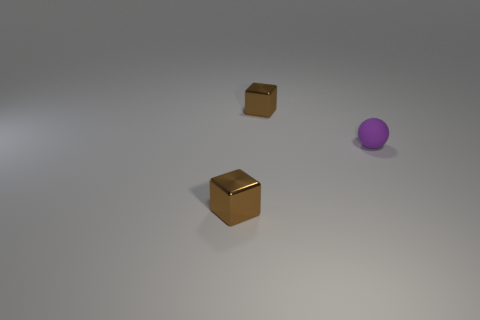What materials do the objects in the image appear to be made of? The objects in the image seem to be made of different materials. The smaller cube in the back appears to have a texture reminiscent of cardboard, while the larger, shiny cube in the foreground suggests a metallic composition. The purple object has a smooth surface which might indicate a plastic or painted wooden material. 